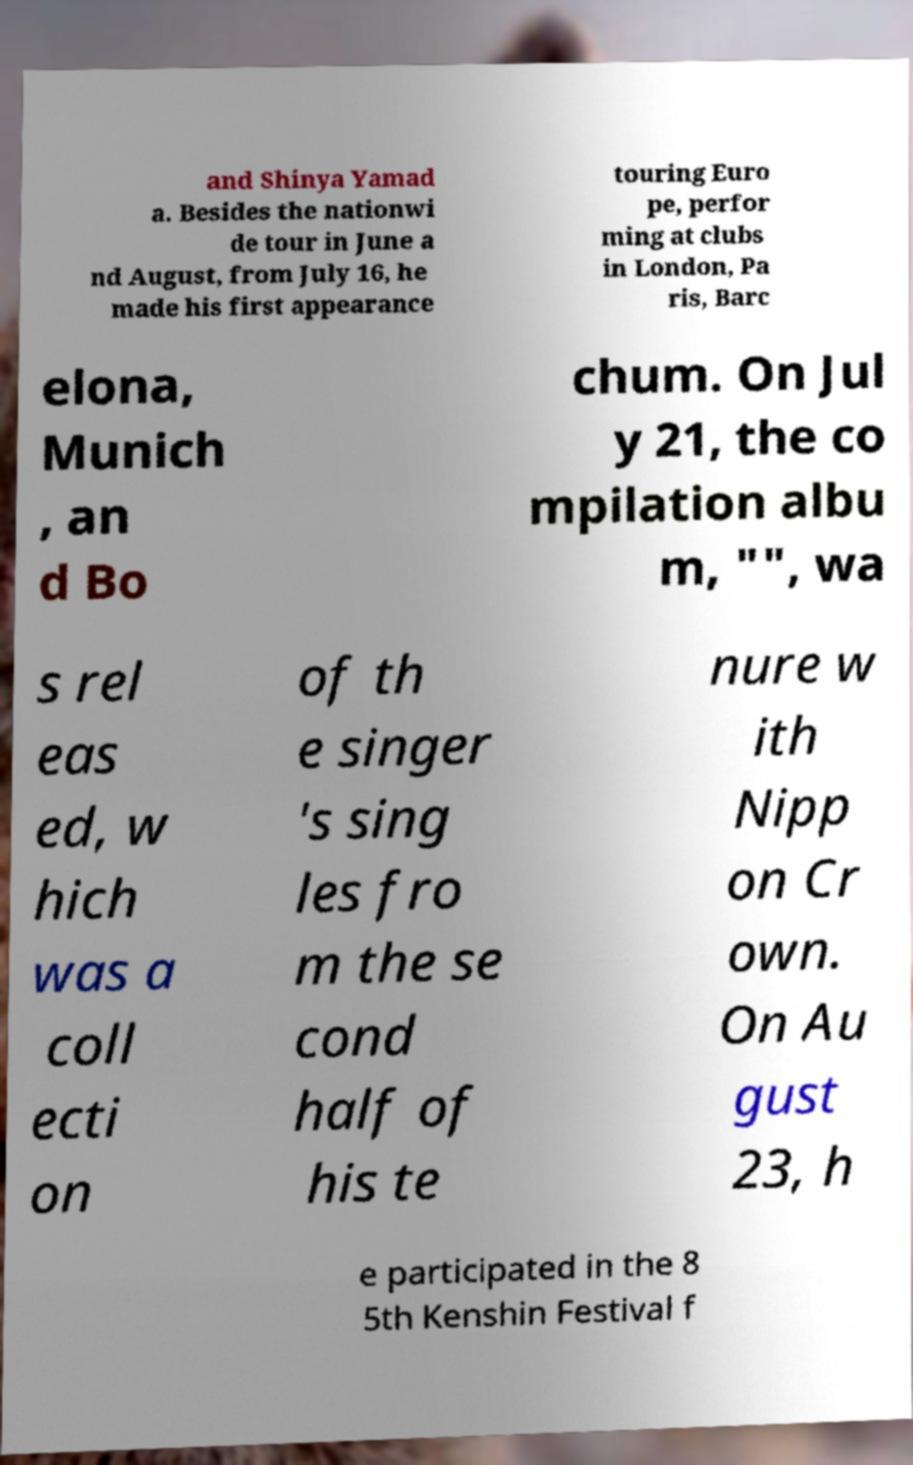Could you assist in decoding the text presented in this image and type it out clearly? and Shinya Yamad a. Besides the nationwi de tour in June a nd August, from July 16, he made his first appearance touring Euro pe, perfor ming at clubs in London, Pa ris, Barc elona, Munich , an d Bo chum. On Jul y 21, the co mpilation albu m, "", wa s rel eas ed, w hich was a coll ecti on of th e singer 's sing les fro m the se cond half of his te nure w ith Nipp on Cr own. On Au gust 23, h e participated in the 8 5th Kenshin Festival f 